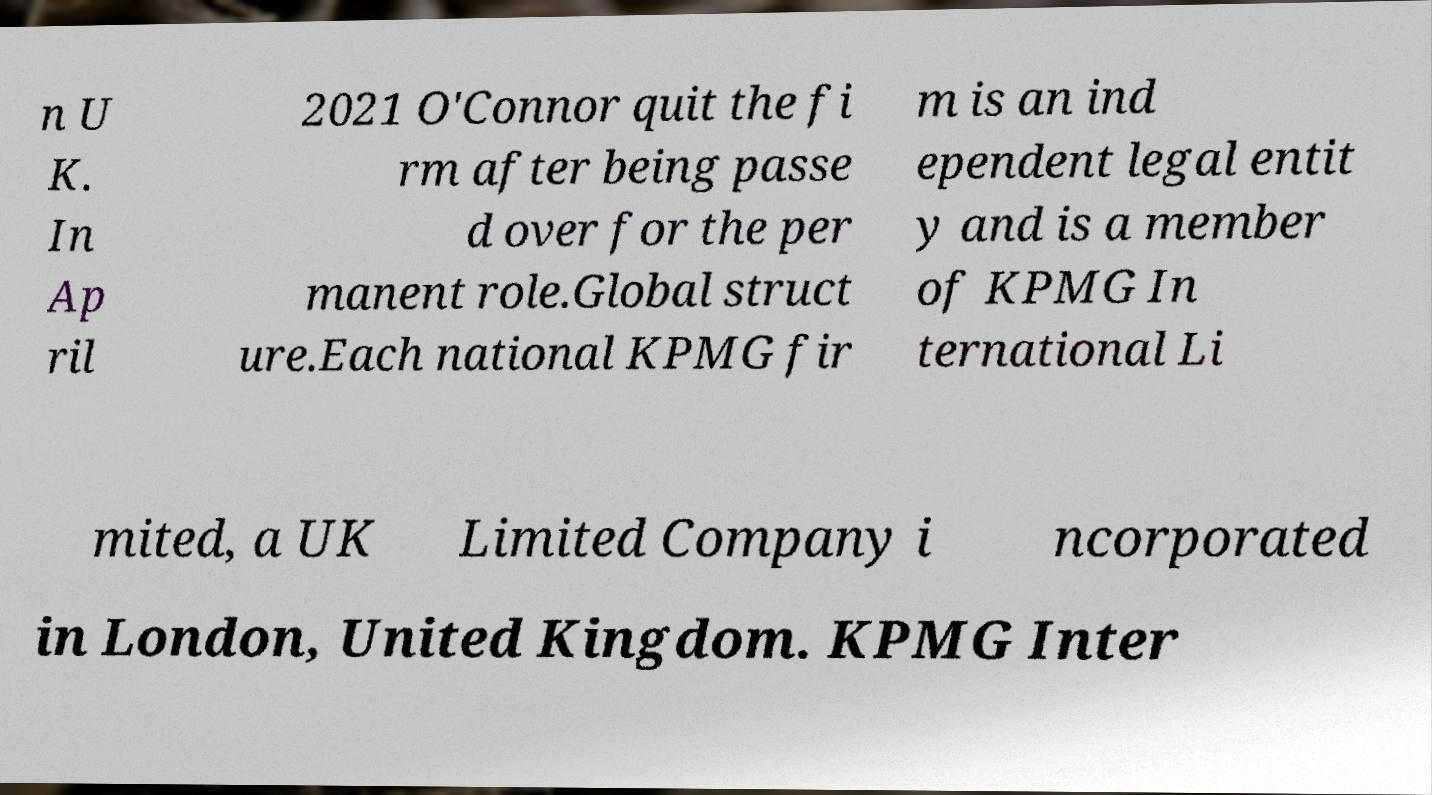Can you accurately transcribe the text from the provided image for me? n U K. In Ap ril 2021 O'Connor quit the fi rm after being passe d over for the per manent role.Global struct ure.Each national KPMG fir m is an ind ependent legal entit y and is a member of KPMG In ternational Li mited, a UK Limited Company i ncorporated in London, United Kingdom. KPMG Inter 